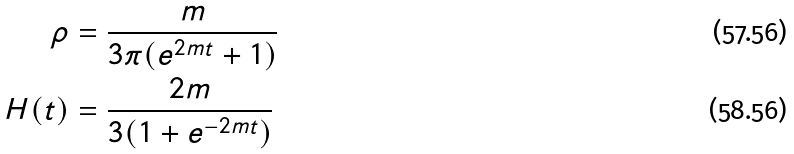<formula> <loc_0><loc_0><loc_500><loc_500>\rho & = \frac { m } { 3 \pi ( e ^ { 2 m t } + 1 ) } \\ H ( t ) & = \frac { 2 m } { 3 ( 1 + e ^ { - 2 m t } ) }</formula> 